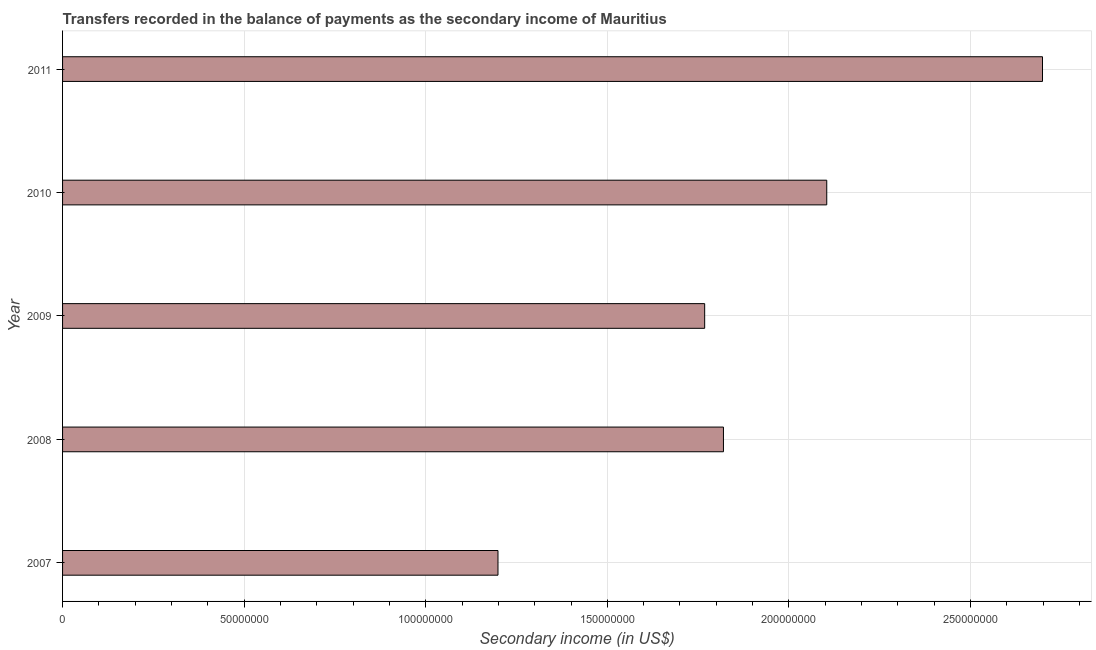Does the graph contain any zero values?
Provide a succinct answer. No. What is the title of the graph?
Offer a very short reply. Transfers recorded in the balance of payments as the secondary income of Mauritius. What is the label or title of the X-axis?
Your answer should be very brief. Secondary income (in US$). What is the amount of secondary income in 2007?
Make the answer very short. 1.20e+08. Across all years, what is the maximum amount of secondary income?
Offer a very short reply. 2.70e+08. Across all years, what is the minimum amount of secondary income?
Keep it short and to the point. 1.20e+08. In which year was the amount of secondary income minimum?
Ensure brevity in your answer.  2007. What is the sum of the amount of secondary income?
Your answer should be compact. 9.59e+08. What is the difference between the amount of secondary income in 2007 and 2008?
Your answer should be compact. -6.21e+07. What is the average amount of secondary income per year?
Your answer should be compact. 1.92e+08. What is the median amount of secondary income?
Make the answer very short. 1.82e+08. In how many years, is the amount of secondary income greater than 30000000 US$?
Provide a succinct answer. 5. What is the ratio of the amount of secondary income in 2010 to that in 2011?
Your response must be concise. 0.78. What is the difference between the highest and the second highest amount of secondary income?
Provide a succinct answer. 5.94e+07. What is the difference between the highest and the lowest amount of secondary income?
Ensure brevity in your answer.  1.50e+08. How many years are there in the graph?
Your answer should be compact. 5. Are the values on the major ticks of X-axis written in scientific E-notation?
Provide a succinct answer. No. What is the Secondary income (in US$) in 2007?
Make the answer very short. 1.20e+08. What is the Secondary income (in US$) of 2008?
Give a very brief answer. 1.82e+08. What is the Secondary income (in US$) of 2009?
Keep it short and to the point. 1.77e+08. What is the Secondary income (in US$) in 2010?
Your answer should be very brief. 2.10e+08. What is the Secondary income (in US$) of 2011?
Your answer should be very brief. 2.70e+08. What is the difference between the Secondary income (in US$) in 2007 and 2008?
Keep it short and to the point. -6.21e+07. What is the difference between the Secondary income (in US$) in 2007 and 2009?
Your answer should be compact. -5.69e+07. What is the difference between the Secondary income (in US$) in 2007 and 2010?
Make the answer very short. -9.05e+07. What is the difference between the Secondary income (in US$) in 2007 and 2011?
Give a very brief answer. -1.50e+08. What is the difference between the Secondary income (in US$) in 2008 and 2009?
Ensure brevity in your answer.  5.17e+06. What is the difference between the Secondary income (in US$) in 2008 and 2010?
Your answer should be compact. -2.84e+07. What is the difference between the Secondary income (in US$) in 2008 and 2011?
Ensure brevity in your answer.  -8.78e+07. What is the difference between the Secondary income (in US$) in 2009 and 2010?
Your response must be concise. -3.36e+07. What is the difference between the Secondary income (in US$) in 2009 and 2011?
Give a very brief answer. -9.30e+07. What is the difference between the Secondary income (in US$) in 2010 and 2011?
Make the answer very short. -5.94e+07. What is the ratio of the Secondary income (in US$) in 2007 to that in 2008?
Ensure brevity in your answer.  0.66. What is the ratio of the Secondary income (in US$) in 2007 to that in 2009?
Your answer should be very brief. 0.68. What is the ratio of the Secondary income (in US$) in 2007 to that in 2010?
Provide a short and direct response. 0.57. What is the ratio of the Secondary income (in US$) in 2007 to that in 2011?
Your response must be concise. 0.44. What is the ratio of the Secondary income (in US$) in 2008 to that in 2009?
Make the answer very short. 1.03. What is the ratio of the Secondary income (in US$) in 2008 to that in 2010?
Keep it short and to the point. 0.86. What is the ratio of the Secondary income (in US$) in 2008 to that in 2011?
Give a very brief answer. 0.67. What is the ratio of the Secondary income (in US$) in 2009 to that in 2010?
Offer a very short reply. 0.84. What is the ratio of the Secondary income (in US$) in 2009 to that in 2011?
Provide a short and direct response. 0.66. What is the ratio of the Secondary income (in US$) in 2010 to that in 2011?
Offer a very short reply. 0.78. 